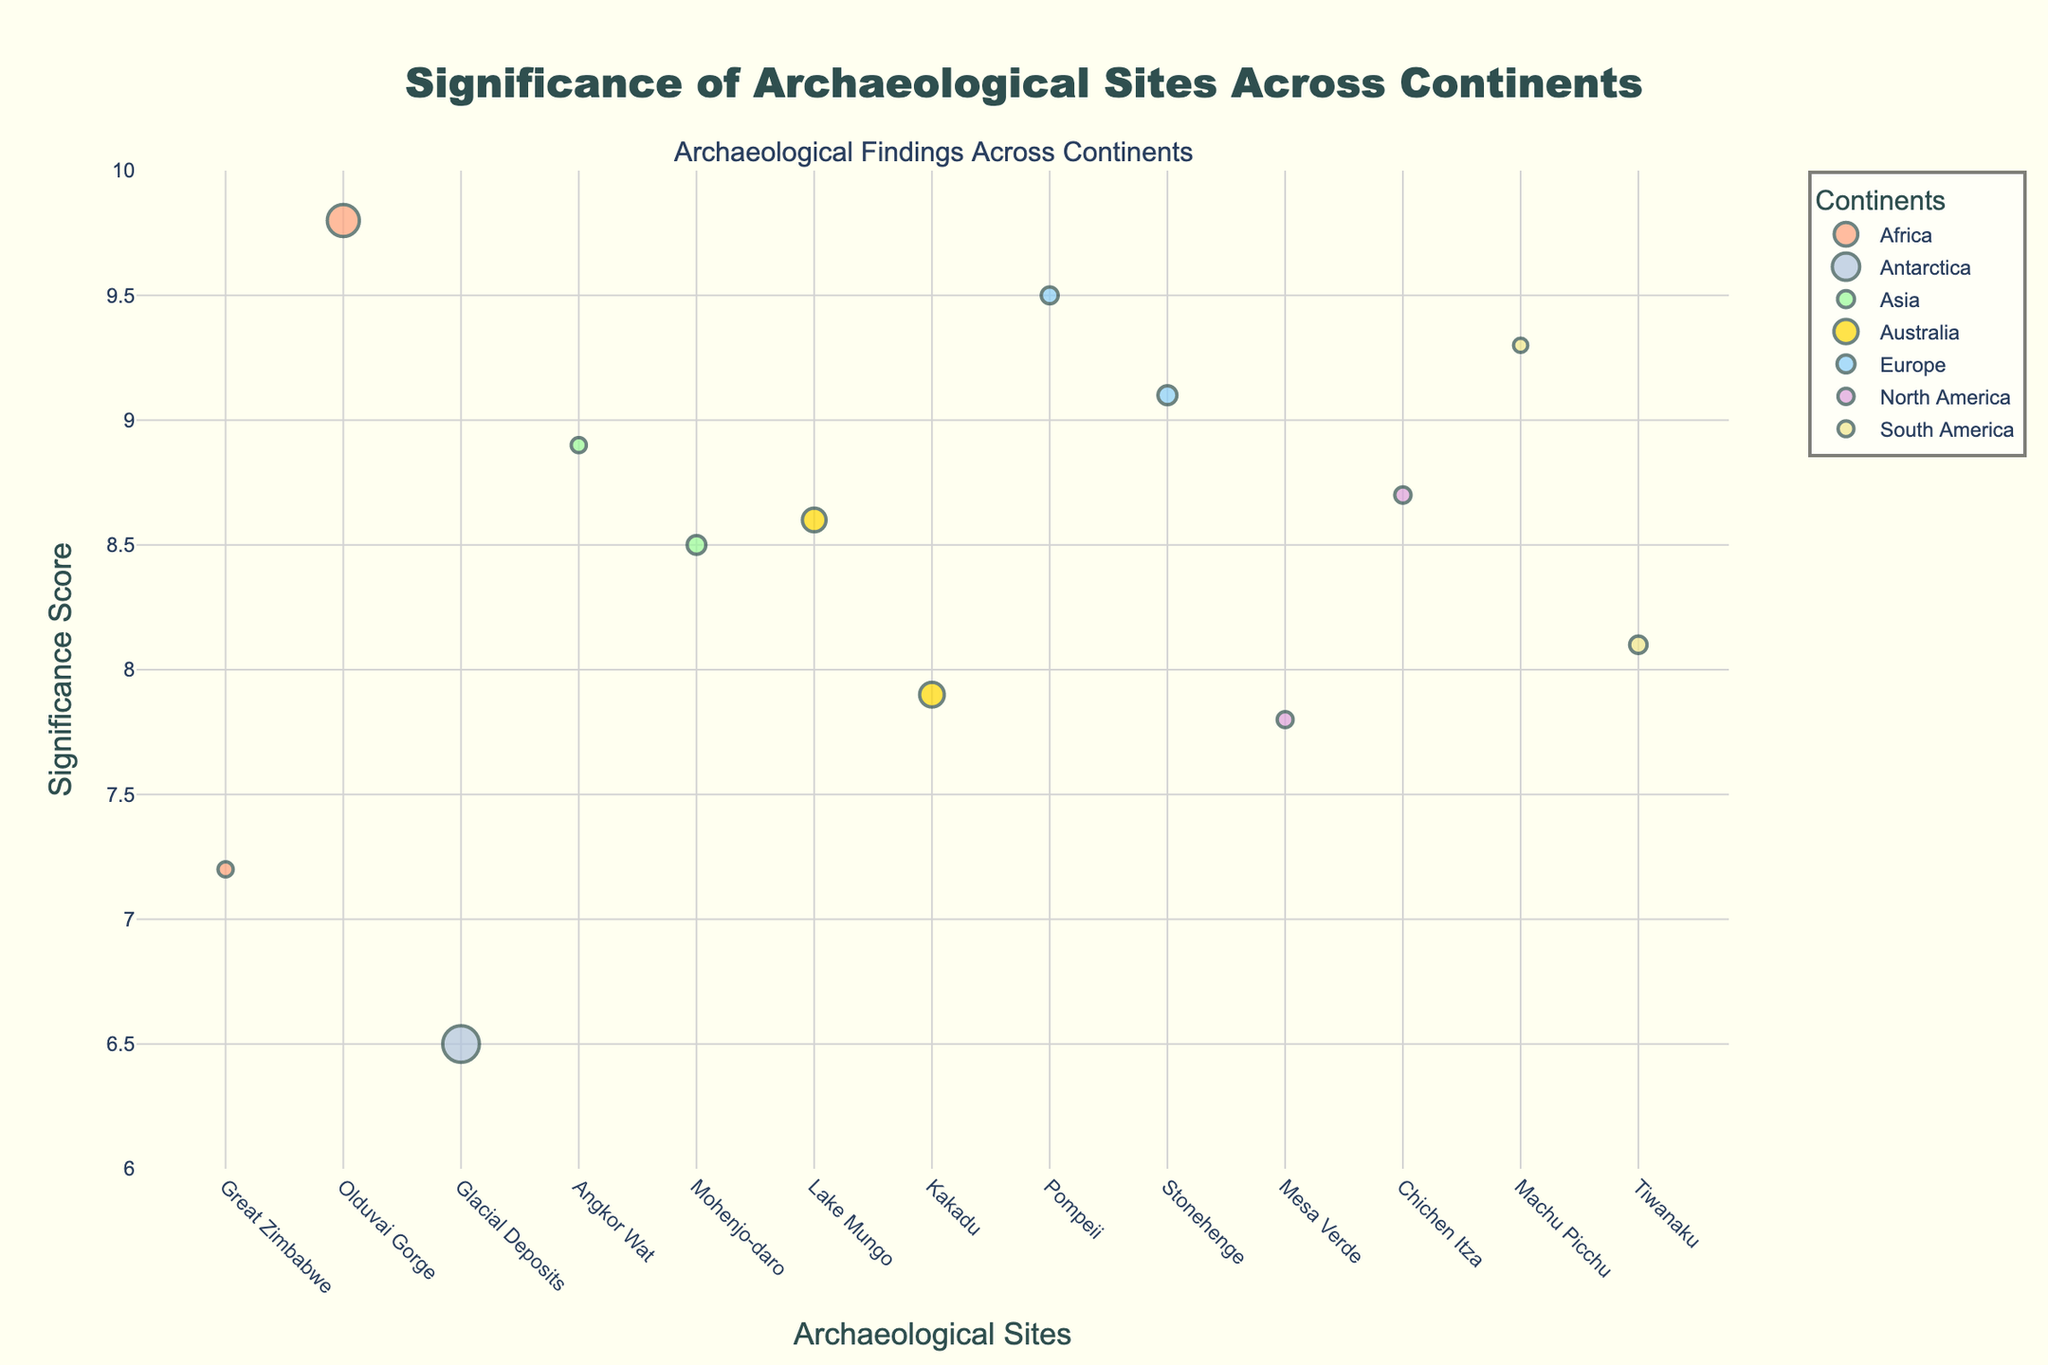What is the title of the plot? The title of the plot is displayed prominently at the top center of the figure. It reads "Significance of Archaeological Sites Across Continents."
Answer: Significance of Archaeological Sites Across Continents What is the significance score of Mohenjo-daro? Locate the marker for Mohenjo-daro on the x-axis. The y-axis value corresponding to that marker indicates the significance score, which is 8.5.
Answer: 8.5 Which site in South America has a higher significance score, Machu Picchu or Tiwanaku? Identify the two sites on the x-axis within the South America color group. Compare their y-axis values to determine which is higher. Machu Picchu (9.3) has a higher score than Tiwanaku (8.1).
Answer: Machu Picchu What does the size of the markers represent in the plot? The size of the markers represents the logarithmic scale of the age of the sites. Larger markers indicate older archaeological sites.
Answer: Logarithmic scale of age How many sites are represented from Africa? Count the number of unique markers that belong to the color corresponding to Africa. There are two markers: Great Zimbabwe and Olduvai Gorge.
Answer: 2 Which continent has the most archaeological sites represented in the plot? Compare the number of markers for each continent by looking at the legend and the x-axis. Africa, Asia, Europe, North America, and South America each have 2 markers, but Australia has 2 markers, while Antarctica has 1 marker.
Answer: Tie between Africa, Asia, Europe, North America, South America, and Australia What is the range of significance scores depicted in the plot? Observe the y-axis values to identify the lowest and highest significance scores among all the markers. The range is from 6.5 to 9.8.
Answer: 6.5 to 9.8 Which site is the oldest, and what is its significance score? Find the site with the smallest y-axis value in the plot, which represents the oldest age. The oldest site is Glacial Deposits in Antarctica, with a significance score of 6.5.
Answer: Glacial Deposits, 6.5 What is the average significance score of archaeological sites from Europe? Identify the significance scores for the sites in Europe (Stonehenge and Pompeii) and calculate their average. (9.1 + 9.5) / 2 = 9.3.
Answer: 9.3 Which continent has the site with the highest significance score, and what is the site's name? Identify the marker with the highest y-axis value in the plot and note the associated site's name and continent. The highest significance score is at Olduvai Gorge in Africa, with a score of 9.8.
Answer: Africa, Olduvai Gorge 